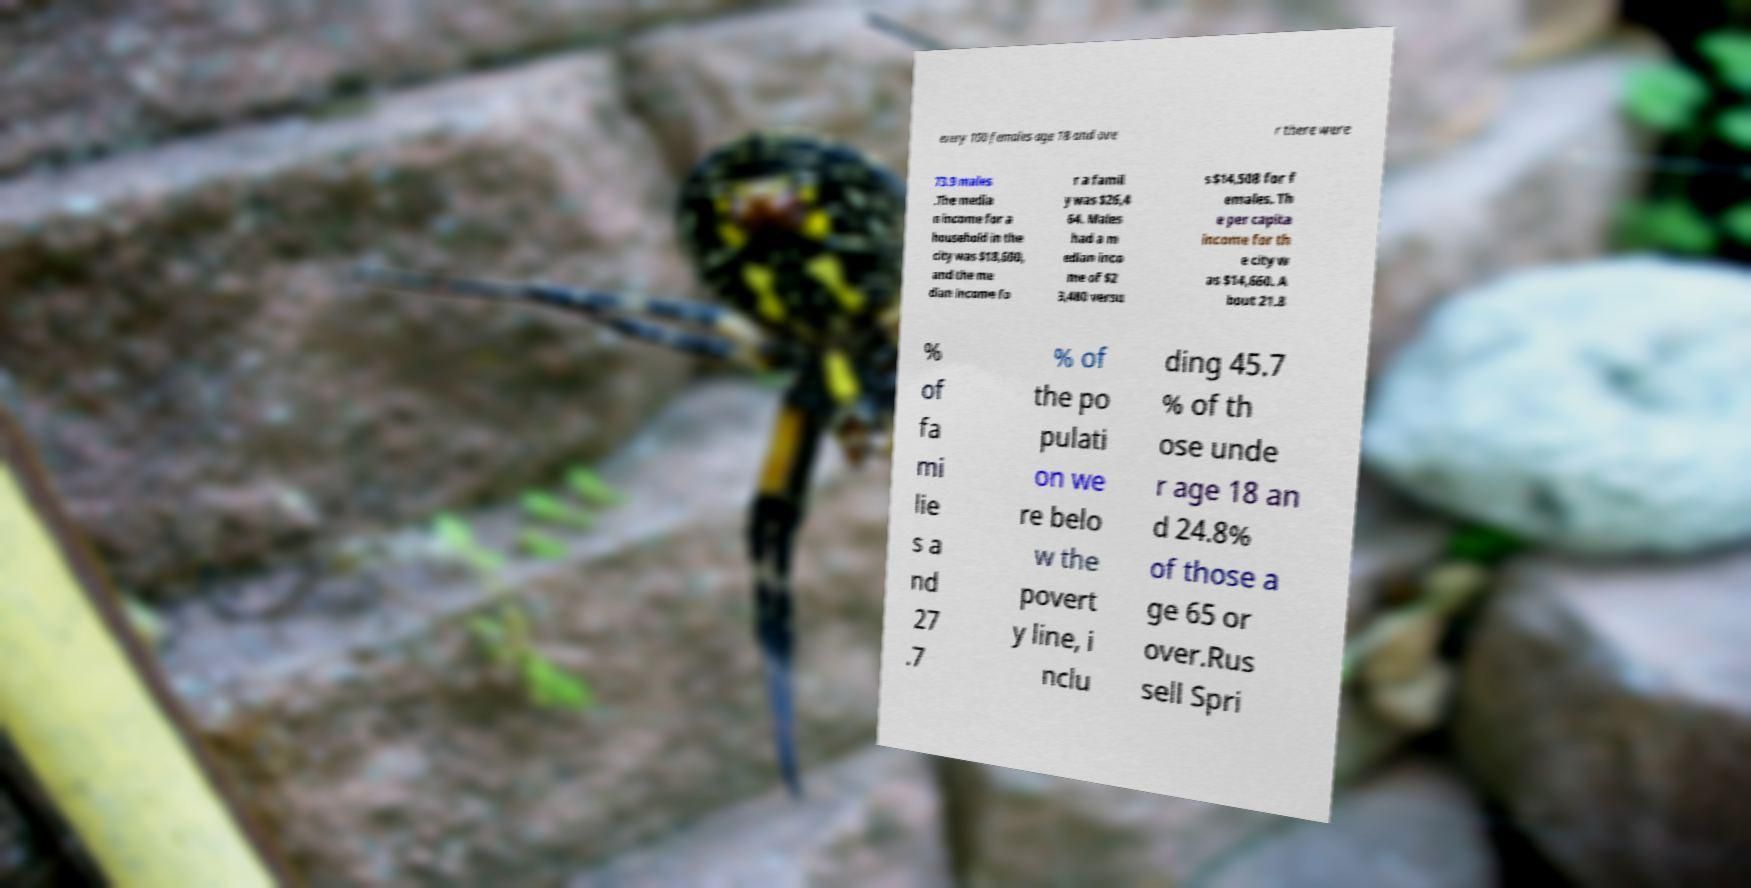There's text embedded in this image that I need extracted. Can you transcribe it verbatim? every 100 females age 18 and ove r there were 73.9 males .The media n income for a household in the city was $18,600, and the me dian income fo r a famil y was $26,4 64. Males had a m edian inco me of $2 3,480 versu s $14,508 for f emales. Th e per capita income for th e city w as $14,660. A bout 21.8 % of fa mi lie s a nd 27 .7 % of the po pulati on we re belo w the povert y line, i nclu ding 45.7 % of th ose unde r age 18 an d 24.8% of those a ge 65 or over.Rus sell Spri 